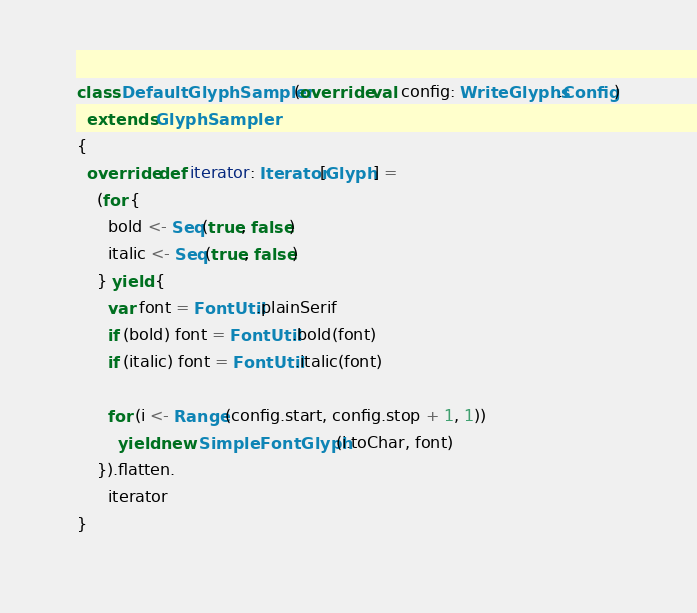Convert code to text. <code><loc_0><loc_0><loc_500><loc_500><_Scala_>class DefaultGlyphSampler(override val config: WriteGlyphs.Config)
  extends GlyphSampler
{
  override def iterator: Iterator[Glyph] =
    (for {
      bold <- Seq(true, false)
      italic <- Seq(true, false)
    } yield {
      var font = FontUtil.plainSerif
      if (bold) font = FontUtil.bold(font)
      if (italic) font = FontUtil.italic(font)

      for (i <- Range(config.start, config.stop + 1, 1))
        yield new SimpleFontGlyph(i.toChar, font)
    }).flatten.
      iterator
}
</code> 